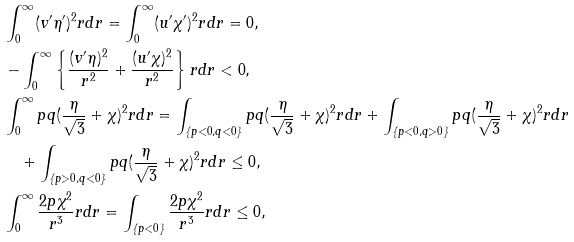Convert formula to latex. <formula><loc_0><loc_0><loc_500><loc_500>& \int _ { 0 } ^ { \infty } ( v ^ { \prime } \eta ^ { \prime } ) ^ { 2 } r d r = \int _ { 0 } ^ { \infty } ( u ^ { \prime } \chi ^ { \prime } ) ^ { 2 } r d r = 0 , \\ & - \int _ { 0 } ^ { \infty } \left \{ \frac { ( v ^ { \prime } \eta ) ^ { 2 } } { r ^ { 2 } } + \frac { ( u ^ { \prime } \chi ) ^ { 2 } } { r ^ { 2 } } \right \} r d r < 0 , \\ & \int _ { 0 } ^ { \infty } p q ( \frac { \eta } { \sqrt { 3 } } + \chi ) ^ { 2 } r d r = \int _ { \{ p < 0 , q < 0 \} } p q ( \frac { \eta } { \sqrt { 3 } } + \chi ) ^ { 2 } r d r + \int _ { \{ p < 0 , q > 0 \} } p q ( \frac { \eta } { \sqrt { 3 } } + \chi ) ^ { 2 } r d r \\ & \quad + \int _ { \{ p > 0 , q < 0 \} } p q ( \frac { \eta } { \sqrt { 3 } } + \chi ) ^ { 2 } r d r \leq 0 , \\ & \int _ { 0 } ^ { \infty } { \frac { 2 p \chi ^ { 2 } } { r ^ { 3 } } } r d r = \int _ { \{ p < 0 \} } { \frac { 2 p \chi ^ { 2 } } { r ^ { 3 } } } r d r \leq 0 ,</formula> 